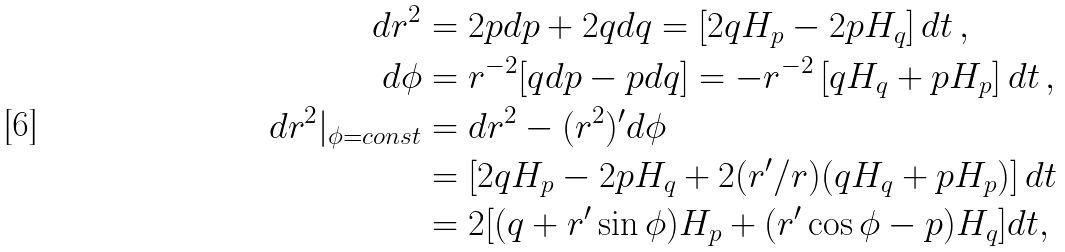Convert formula to latex. <formula><loc_0><loc_0><loc_500><loc_500>d r ^ { 2 } & = 2 p d p + 2 q d q = \left [ 2 q H _ { p } - 2 p H _ { q } \right ] d t \, , \\ d \phi & = r ^ { - 2 } [ q d p - p d q ] = - r ^ { - 2 } \left [ q H _ { q } + p H _ { p } \right ] d t \, , \\ d r ^ { 2 } | _ { \phi = c o n s t } & = d r ^ { 2 } - ( r ^ { 2 } ) ^ { \prime } d \phi \\ & = \left [ 2 q H _ { p } - 2 p H _ { q } + 2 ( r ^ { \prime } / r ) ( q H _ { q } + p H _ { p } ) \right ] d t \\ & = 2 [ ( q + r ^ { \prime } \sin \phi ) H _ { p } + ( r ^ { \prime } \cos \phi - p ) H _ { q } ] d t ,</formula> 